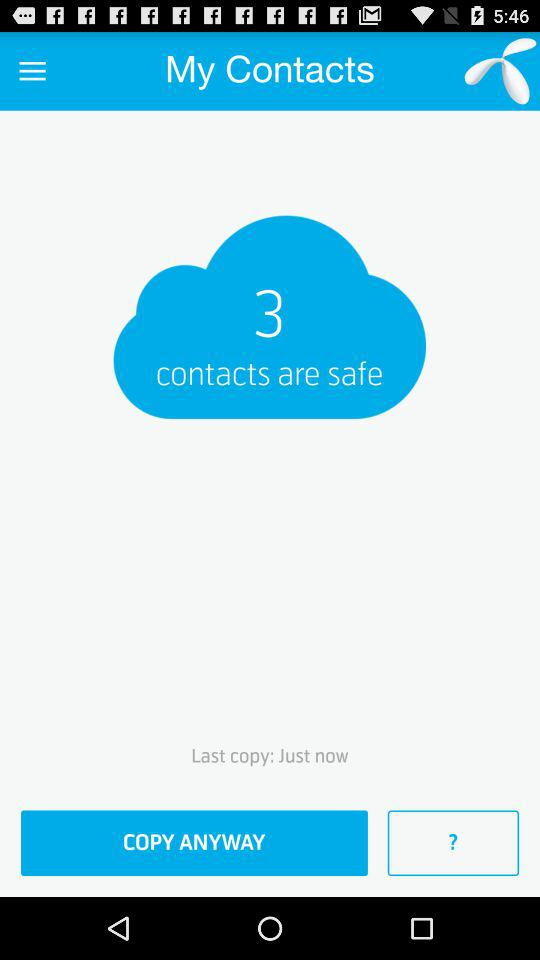How many contacts are safe? There are 3 safe contacts. 